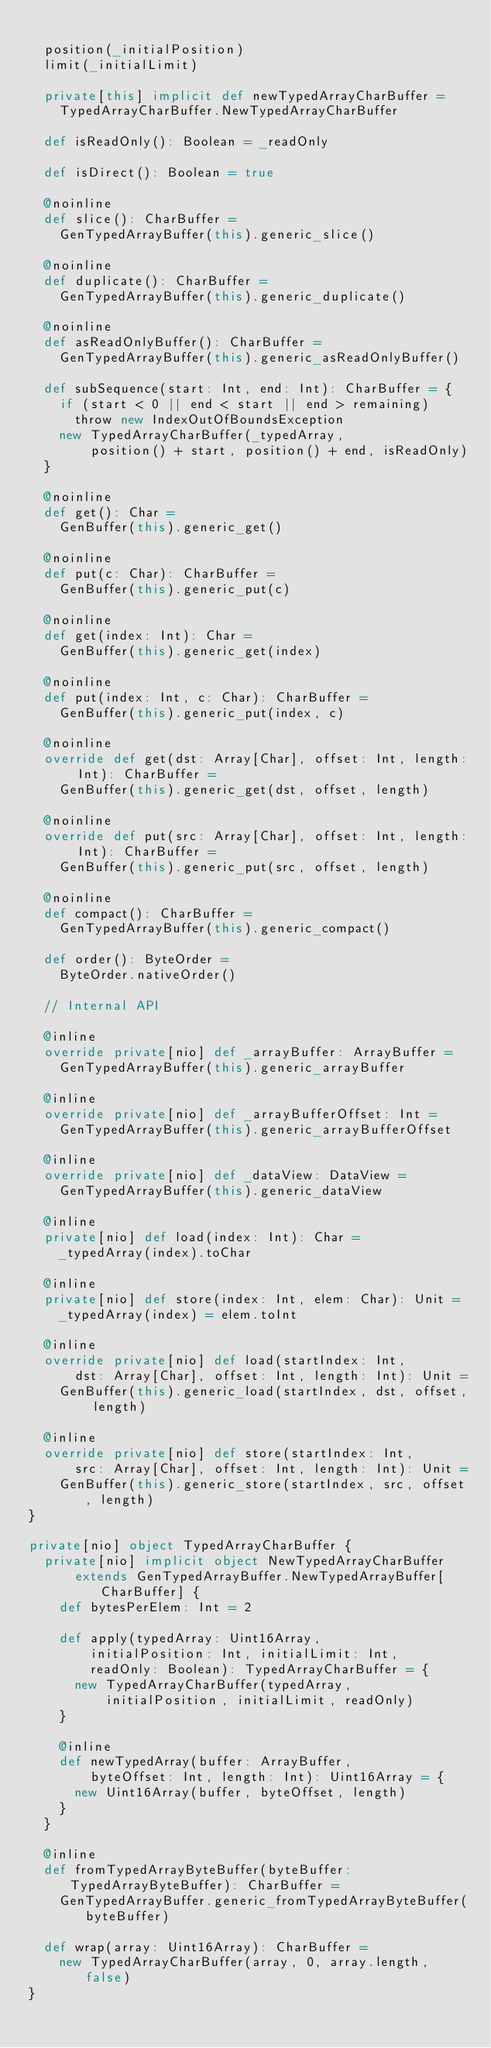<code> <loc_0><loc_0><loc_500><loc_500><_Scala_>
  position(_initialPosition)
  limit(_initialLimit)

  private[this] implicit def newTypedArrayCharBuffer =
    TypedArrayCharBuffer.NewTypedArrayCharBuffer

  def isReadOnly(): Boolean = _readOnly

  def isDirect(): Boolean = true

  @noinline
  def slice(): CharBuffer =
    GenTypedArrayBuffer(this).generic_slice()

  @noinline
  def duplicate(): CharBuffer =
    GenTypedArrayBuffer(this).generic_duplicate()

  @noinline
  def asReadOnlyBuffer(): CharBuffer =
    GenTypedArrayBuffer(this).generic_asReadOnlyBuffer()

  def subSequence(start: Int, end: Int): CharBuffer = {
    if (start < 0 || end < start || end > remaining)
      throw new IndexOutOfBoundsException
    new TypedArrayCharBuffer(_typedArray,
        position() + start, position() + end, isReadOnly)
  }

  @noinline
  def get(): Char =
    GenBuffer(this).generic_get()

  @noinline
  def put(c: Char): CharBuffer =
    GenBuffer(this).generic_put(c)

  @noinline
  def get(index: Int): Char =
    GenBuffer(this).generic_get(index)

  @noinline
  def put(index: Int, c: Char): CharBuffer =
    GenBuffer(this).generic_put(index, c)

  @noinline
  override def get(dst: Array[Char], offset: Int, length: Int): CharBuffer =
    GenBuffer(this).generic_get(dst, offset, length)

  @noinline
  override def put(src: Array[Char], offset: Int, length: Int): CharBuffer =
    GenBuffer(this).generic_put(src, offset, length)

  @noinline
  def compact(): CharBuffer =
    GenTypedArrayBuffer(this).generic_compact()

  def order(): ByteOrder =
    ByteOrder.nativeOrder()

  // Internal API

  @inline
  override private[nio] def _arrayBuffer: ArrayBuffer =
    GenTypedArrayBuffer(this).generic_arrayBuffer

  @inline
  override private[nio] def _arrayBufferOffset: Int =
    GenTypedArrayBuffer(this).generic_arrayBufferOffset

  @inline
  override private[nio] def _dataView: DataView =
    GenTypedArrayBuffer(this).generic_dataView

  @inline
  private[nio] def load(index: Int): Char =
    _typedArray(index).toChar

  @inline
  private[nio] def store(index: Int, elem: Char): Unit =
    _typedArray(index) = elem.toInt

  @inline
  override private[nio] def load(startIndex: Int,
      dst: Array[Char], offset: Int, length: Int): Unit =
    GenBuffer(this).generic_load(startIndex, dst, offset, length)

  @inline
  override private[nio] def store(startIndex: Int,
      src: Array[Char], offset: Int, length: Int): Unit =
    GenBuffer(this).generic_store(startIndex, src, offset, length)
}

private[nio] object TypedArrayCharBuffer {
  private[nio] implicit object NewTypedArrayCharBuffer
      extends GenTypedArrayBuffer.NewTypedArrayBuffer[CharBuffer] {
    def bytesPerElem: Int = 2

    def apply(typedArray: Uint16Array,
        initialPosition: Int, initialLimit: Int,
        readOnly: Boolean): TypedArrayCharBuffer = {
      new TypedArrayCharBuffer(typedArray,
          initialPosition, initialLimit, readOnly)
    }

    @inline
    def newTypedArray(buffer: ArrayBuffer,
        byteOffset: Int, length: Int): Uint16Array = {
      new Uint16Array(buffer, byteOffset, length)
    }
  }

  @inline
  def fromTypedArrayByteBuffer(byteBuffer: TypedArrayByteBuffer): CharBuffer =
    GenTypedArrayBuffer.generic_fromTypedArrayByteBuffer(byteBuffer)

  def wrap(array: Uint16Array): CharBuffer =
    new TypedArrayCharBuffer(array, 0, array.length, false)
}
</code> 